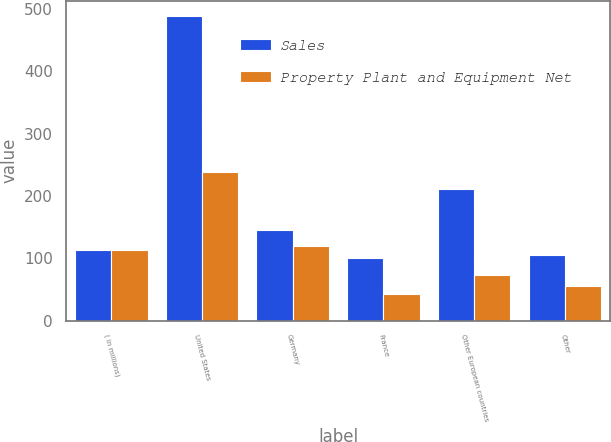<chart> <loc_0><loc_0><loc_500><loc_500><stacked_bar_chart><ecel><fcel>( in millions)<fcel>United States<fcel>Germany<fcel>France<fcel>Other European countries<fcel>Other<nl><fcel>Sales<fcel>112.45<fcel>488.5<fcel>145.4<fcel>100.7<fcel>211.5<fcel>105<nl><fcel>Property Plant and Equipment Net<fcel>112.45<fcel>238.9<fcel>119.9<fcel>43.4<fcel>72.6<fcel>56.2<nl></chart> 